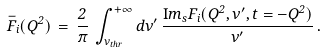Convert formula to latex. <formula><loc_0><loc_0><loc_500><loc_500>\bar { F } _ { i } ( Q ^ { 2 } ) \, = \, { \frac { 2 } { \pi } } \, \int _ { \nu _ { t h r } } ^ { + \infty } d \nu ^ { \prime } \, { \frac { { \mathrm I m } _ { s } F _ { i } ( Q ^ { 2 } , \nu ^ { \prime } , t = - Q ^ { 2 } ) } { \nu ^ { \prime } } } \, .</formula> 